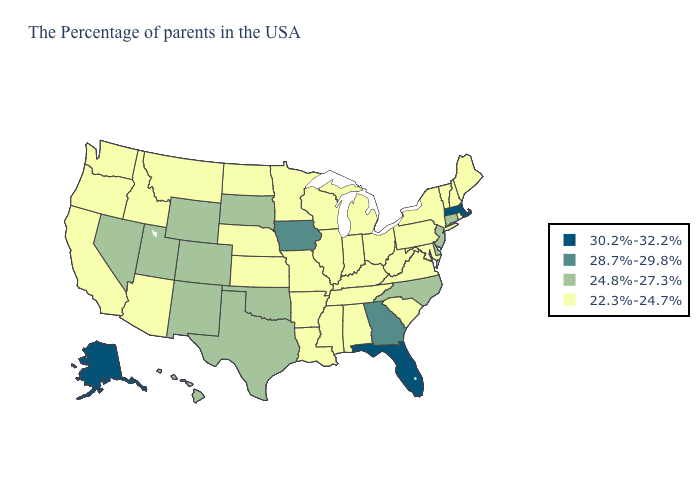What is the lowest value in the USA?
Answer briefly. 22.3%-24.7%. Does Connecticut have the lowest value in the USA?
Concise answer only. No. What is the lowest value in the USA?
Concise answer only. 22.3%-24.7%. Does the first symbol in the legend represent the smallest category?
Concise answer only. No. Name the states that have a value in the range 30.2%-32.2%?
Short answer required. Massachusetts, Florida, Alaska. What is the lowest value in states that border Missouri?
Be succinct. 22.3%-24.7%. What is the value of Oklahoma?
Keep it brief. 24.8%-27.3%. Does Massachusetts have the highest value in the USA?
Be succinct. Yes. What is the lowest value in the South?
Answer briefly. 22.3%-24.7%. Name the states that have a value in the range 24.8%-27.3%?
Quick response, please. Connecticut, New Jersey, Delaware, North Carolina, Oklahoma, Texas, South Dakota, Wyoming, Colorado, New Mexico, Utah, Nevada, Hawaii. What is the lowest value in the USA?
Answer briefly. 22.3%-24.7%. What is the highest value in states that border Maryland?
Concise answer only. 24.8%-27.3%. Name the states that have a value in the range 22.3%-24.7%?
Give a very brief answer. Maine, Rhode Island, New Hampshire, Vermont, New York, Maryland, Pennsylvania, Virginia, South Carolina, West Virginia, Ohio, Michigan, Kentucky, Indiana, Alabama, Tennessee, Wisconsin, Illinois, Mississippi, Louisiana, Missouri, Arkansas, Minnesota, Kansas, Nebraska, North Dakota, Montana, Arizona, Idaho, California, Washington, Oregon. What is the value of Louisiana?
Be succinct. 22.3%-24.7%. Which states have the lowest value in the USA?
Answer briefly. Maine, Rhode Island, New Hampshire, Vermont, New York, Maryland, Pennsylvania, Virginia, South Carolina, West Virginia, Ohio, Michigan, Kentucky, Indiana, Alabama, Tennessee, Wisconsin, Illinois, Mississippi, Louisiana, Missouri, Arkansas, Minnesota, Kansas, Nebraska, North Dakota, Montana, Arizona, Idaho, California, Washington, Oregon. 